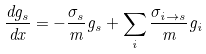Convert formula to latex. <formula><loc_0><loc_0><loc_500><loc_500>\frac { d g _ { s } } { d x } = - \frac { \sigma _ { s } } { m } g _ { s } + \sum _ { i } \frac { \sigma _ { i \rightarrow s } } { m } g _ { i }</formula> 